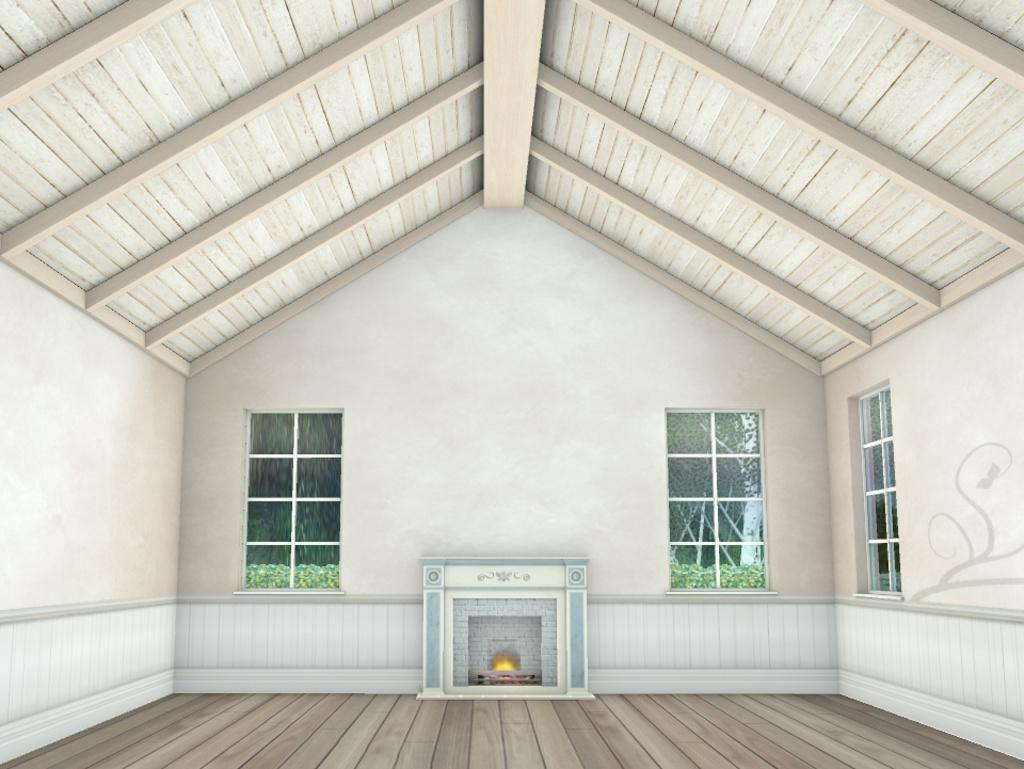Where was the image taken? The image was taken indoors. Can you describe any editing that has been done to the image? The image appears to be edited. What is the main feature in the front of the image? There is a fireplace in the front of the image. What is at the bottom of the image? There is a floor at the bottom of the image. What is on the wall in the front of the image? There is a wall in the front of the image, and there are windows on the wall. What type of drink is being served in the scene? There is no scene or drink present in the image; it is a still image of a room with a fireplace, wall, and windows. 